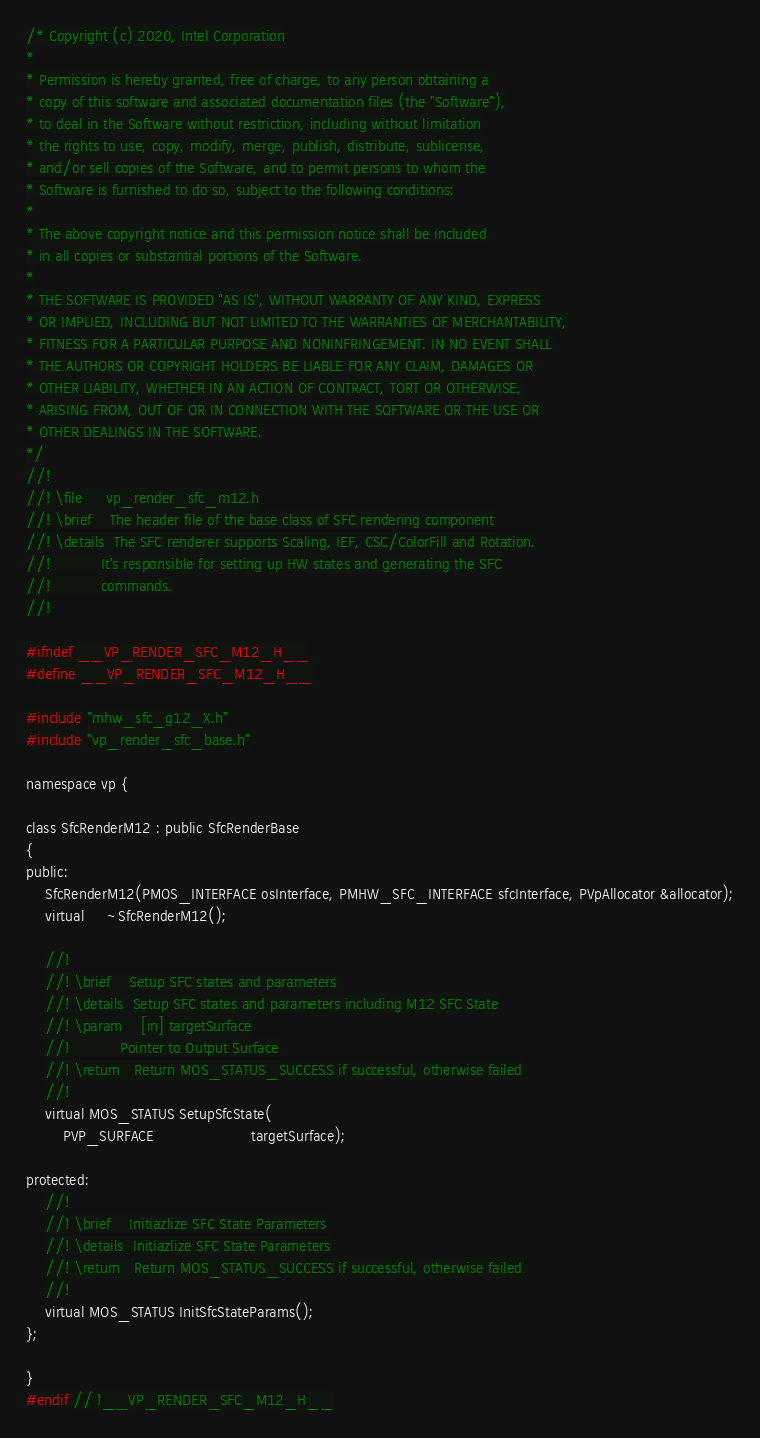<code> <loc_0><loc_0><loc_500><loc_500><_C_>/* Copyright (c) 2020, Intel Corporation
*
* Permission is hereby granted, free of charge, to any person obtaining a
* copy of this software and associated documentation files (the "Software"),
* to deal in the Software without restriction, including without limitation
* the rights to use, copy, modify, merge, publish, distribute, sublicense,
* and/or sell copies of the Software, and to permit persons to whom the
* Software is furnished to do so, subject to the following conditions:
*
* The above copyright notice and this permission notice shall be included
* in all copies or substantial portions of the Software.
*
* THE SOFTWARE IS PROVIDED "AS IS", WITHOUT WARRANTY OF ANY KIND, EXPRESS
* OR IMPLIED, INCLUDING BUT NOT LIMITED TO THE WARRANTIES OF MERCHANTABILITY,
* FITNESS FOR A PARTICULAR PURPOSE AND NONINFRINGEMENT. IN NO EVENT SHALL
* THE AUTHORS OR COPYRIGHT HOLDERS BE LIABLE FOR ANY CLAIM, DAMAGES OR
* OTHER LIABILITY, WHETHER IN AN ACTION OF CONTRACT, TORT OR OTHERWISE,
* ARISING FROM, OUT OF OR IN CONNECTION WITH THE SOFTWARE OR THE USE OR
* OTHER DEALINGS IN THE SOFTWARE.
*/
//!
//! \file     vp_render_sfc_m12.h
//! \brief    The header file of the base class of SFC rendering component
//! \details  The SFC renderer supports Scaling, IEF, CSC/ColorFill and Rotation.
//!           It's responsible for setting up HW states and generating the SFC
//!           commands.
//!

#ifndef __VP_RENDER_SFC_M12_H__
#define __VP_RENDER_SFC_M12_H__

#include "mhw_sfc_g12_X.h"
#include "vp_render_sfc_base.h"

namespace vp {

class SfcRenderM12 : public SfcRenderBase
{
public:
    SfcRenderM12(PMOS_INTERFACE osInterface, PMHW_SFC_INTERFACE sfcInterface, PVpAllocator &allocator);
    virtual     ~SfcRenderM12();

    //!
    //! \brief    Setup SFC states and parameters
    //! \details  Setup SFC states and parameters including M12 SFC State
    //! \param    [in] targetSurface
    //!           Pointer to Output Surface
    //! \return   Return MOS_STATUS_SUCCESS if successful, otherwise failed
    //!
    virtual MOS_STATUS SetupSfcState(
        PVP_SURFACE                     targetSurface);

protected:
    //!
    //! \brief    Initiazlize SFC State Parameters
    //! \details  Initiazlize SFC State Parameters
    //! \return   Return MOS_STATUS_SUCCESS if successful, otherwise failed
    //!
    virtual MOS_STATUS InitSfcStateParams();
};

}
#endif // !__VP_RENDER_SFC_M12_H__
</code> 